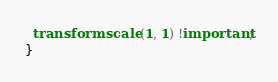Convert code to text. <code><loc_0><loc_0><loc_500><loc_500><_CSS_>  transform: scale(1, 1) !important;
}
</code> 